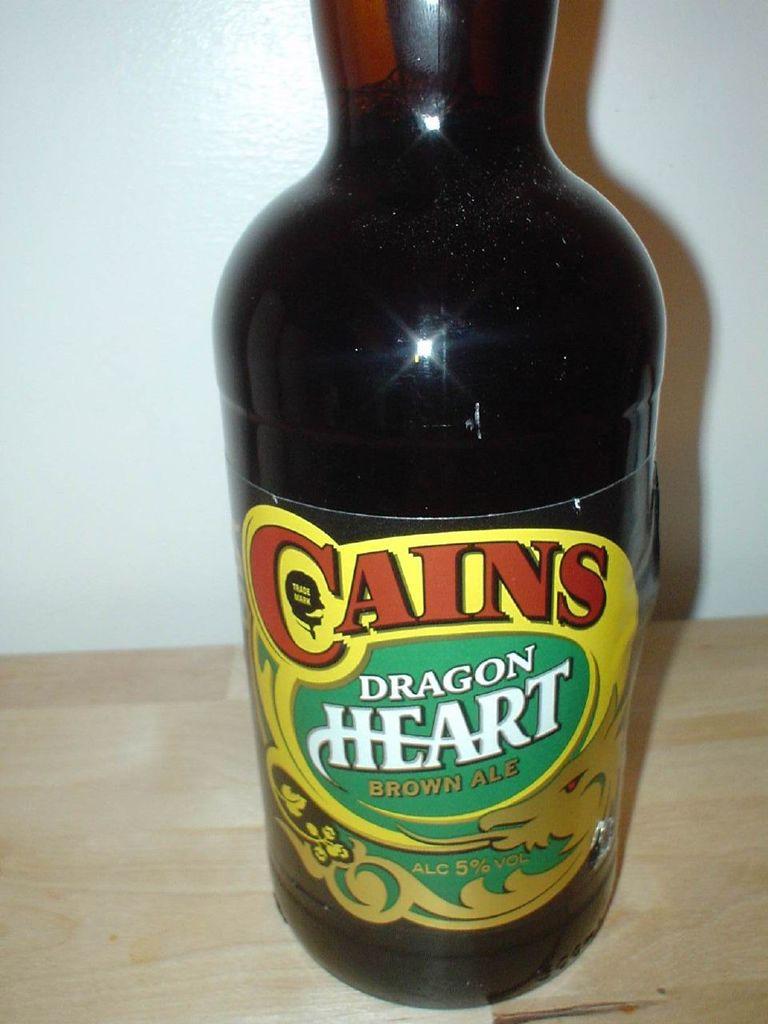What is this called?
Your answer should be compact. Cains dragon heart brown ale. What brand of beer is this?
Offer a terse response. Cains. 